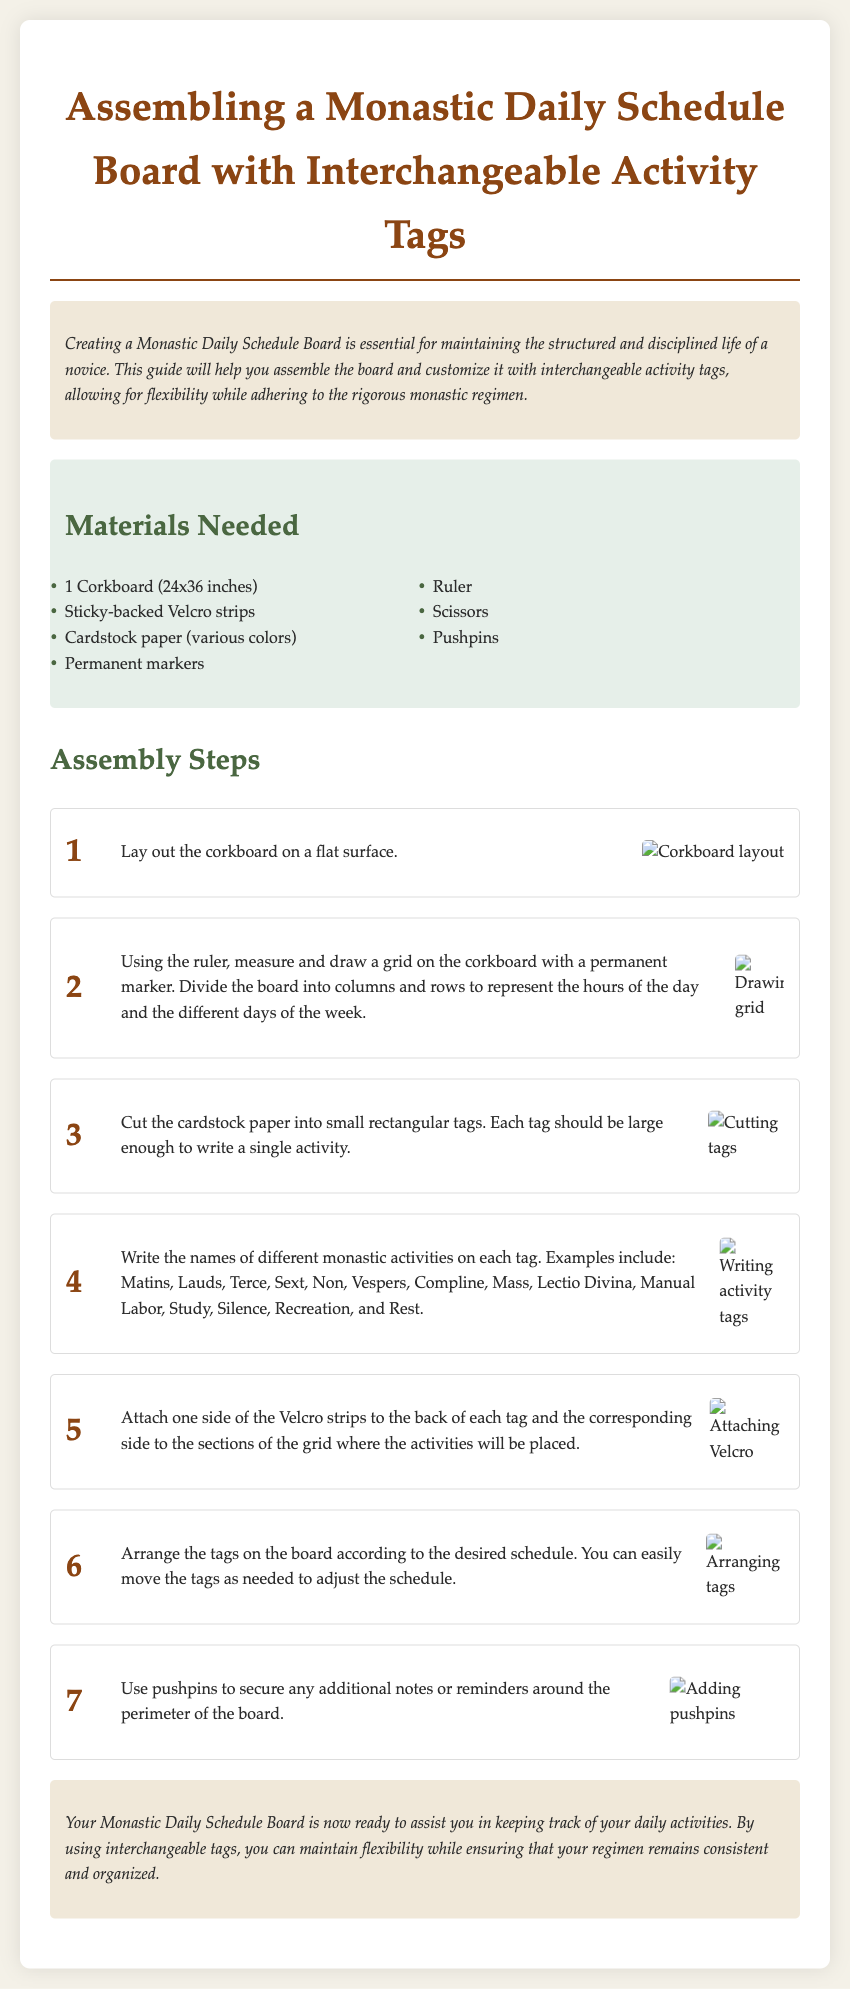what size is the corkboard? The corkboard is specified in the materials section as 24x36 inches.
Answer: 24x36 inches how many activity tags should be prepared? Each tag should be large enough to write a single activity, and the document lists several activities but does not specify an exact number, so one could infer to prepare tags for each activity listed.
Answer: Several what materials are needed for the project? The materials section lists several needed items, including corkboard, Velcro strips, cardstock, markers, ruler, scissors, and pushpins.
Answer: Corkboard, Velcro strips, cardstock, markers, ruler, scissors, pushpins how many steps are in the assembly instructions? The document outlines seven specific steps for assembling the schedule board.
Answer: 7 what is the purpose of the schedule board? The introduction describes the purpose as maintaining the structured and disciplined life of a novice.
Answer: Maintaining structure which activity is not listed among the tags? The document specifies activities to write on the tags, and the question asks for an activity that is not mentioned; for example, "Sleep" is not included in the list.
Answer: Sleep what type of adhesive is used for attaching tags? The assembly instructions specify using sticky-backed Velcro strips for attaching the tags.
Answer: Velcro strips where can additional notes or reminders be secured? The final assembly step mentions using pushpins to secure additional notes or reminders around the perimeter of the board.
Answer: Around the perimeter what color scheme is used in the document? The document uses a color scheme that includes earth tones and pastels, specifically mentioned in the styling and background descriptions.
Answer: Earth tones and pastels 